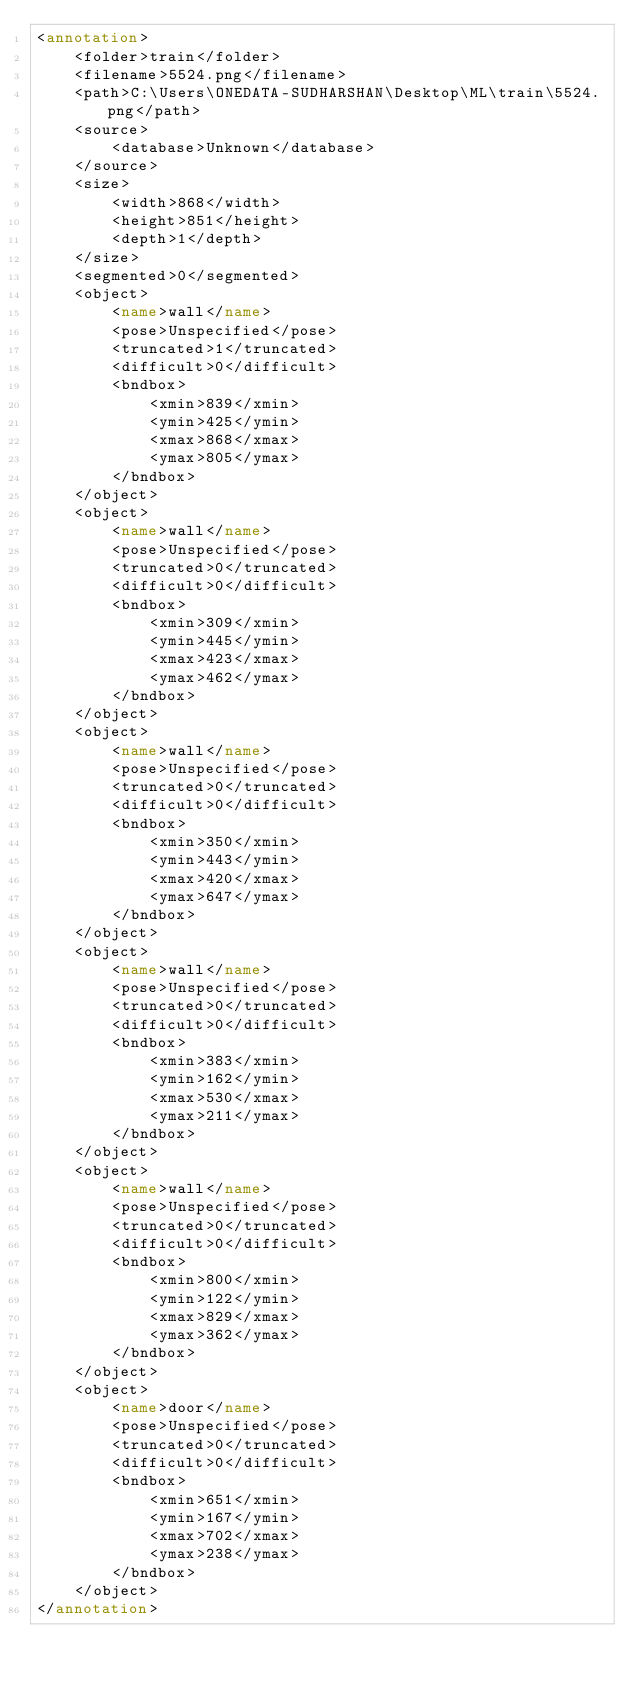<code> <loc_0><loc_0><loc_500><loc_500><_XML_><annotation>
	<folder>train</folder>
	<filename>5524.png</filename>
	<path>C:\Users\ONEDATA-SUDHARSHAN\Desktop\ML\train\5524.png</path>
	<source>
		<database>Unknown</database>
	</source>
	<size>
		<width>868</width>
		<height>851</height>
		<depth>1</depth>
	</size>
	<segmented>0</segmented>
	<object>
		<name>wall</name>
		<pose>Unspecified</pose>
		<truncated>1</truncated>
		<difficult>0</difficult>
		<bndbox>
			<xmin>839</xmin>
			<ymin>425</ymin>
			<xmax>868</xmax>
			<ymax>805</ymax>
		</bndbox>
	</object>
	<object>
		<name>wall</name>
		<pose>Unspecified</pose>
		<truncated>0</truncated>
		<difficult>0</difficult>
		<bndbox>
			<xmin>309</xmin>
			<ymin>445</ymin>
			<xmax>423</xmax>
			<ymax>462</ymax>
		</bndbox>
	</object>
	<object>
		<name>wall</name>
		<pose>Unspecified</pose>
		<truncated>0</truncated>
		<difficult>0</difficult>
		<bndbox>
			<xmin>350</xmin>
			<ymin>443</ymin>
			<xmax>420</xmax>
			<ymax>647</ymax>
		</bndbox>
	</object>
	<object>
		<name>wall</name>
		<pose>Unspecified</pose>
		<truncated>0</truncated>
		<difficult>0</difficult>
		<bndbox>
			<xmin>383</xmin>
			<ymin>162</ymin>
			<xmax>530</xmax>
			<ymax>211</ymax>
		</bndbox>
	</object>
	<object>
		<name>wall</name>
		<pose>Unspecified</pose>
		<truncated>0</truncated>
		<difficult>0</difficult>
		<bndbox>
			<xmin>800</xmin>
			<ymin>122</ymin>
			<xmax>829</xmax>
			<ymax>362</ymax>
		</bndbox>
	</object>
	<object>
		<name>door</name>
		<pose>Unspecified</pose>
		<truncated>0</truncated>
		<difficult>0</difficult>
		<bndbox>
			<xmin>651</xmin>
			<ymin>167</ymin>
			<xmax>702</xmax>
			<ymax>238</ymax>
		</bndbox>
	</object>
</annotation>
</code> 